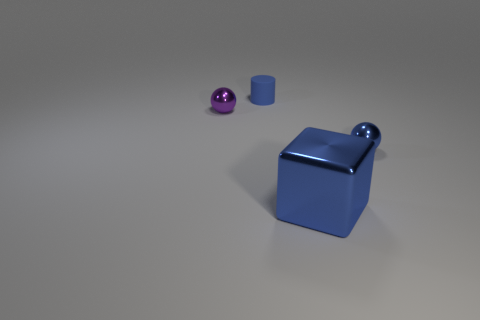Does the thing to the left of the small blue rubber cylinder have the same shape as the tiny blue matte thing?
Your answer should be compact. No. Are there any purple spheres?
Your answer should be compact. Yes. Is there anything else that is the same shape as the big metal thing?
Your answer should be compact. No. Are there more tiny blue matte things that are in front of the blue ball than small blue rubber cylinders?
Provide a succinct answer. No. There is a blue ball; are there any metal spheres to the left of it?
Your answer should be compact. Yes. Does the cylinder have the same size as the purple object?
Offer a very short reply. Yes. Is there any other thing that has the same size as the cube?
Provide a succinct answer. No. The blue thing that is behind the tiny shiny ball that is behind the blue ball is made of what material?
Keep it short and to the point. Rubber. Do the small blue shiny object and the large blue thing have the same shape?
Ensure brevity in your answer.  No. What number of metallic things are both behind the blue shiny ball and in front of the blue shiny sphere?
Provide a short and direct response. 0. 